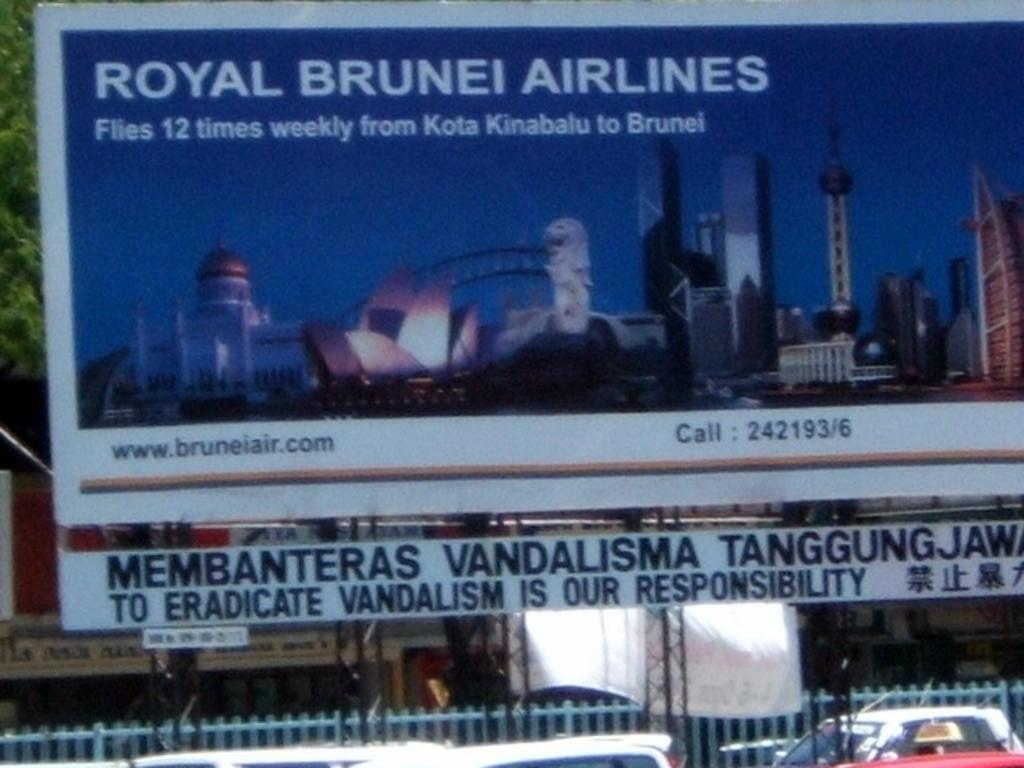<image>
Offer a succinct explanation of the picture presented. a billboard for Royal Brunei Airlines displayed outside 